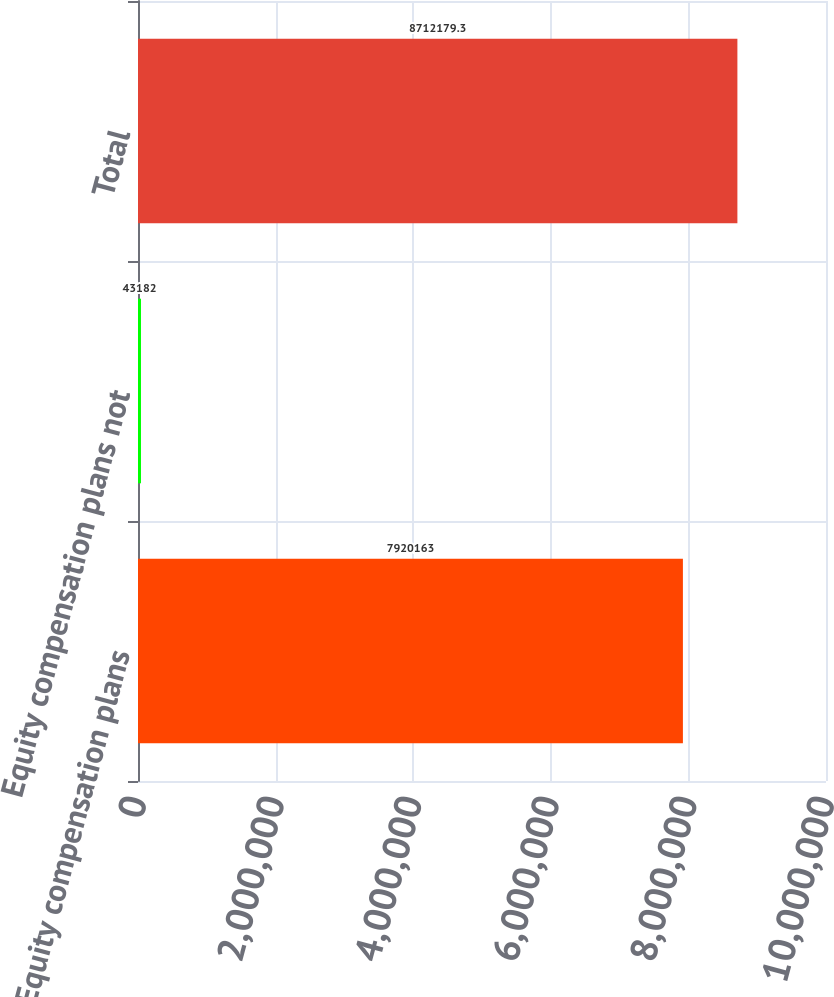Convert chart to OTSL. <chart><loc_0><loc_0><loc_500><loc_500><bar_chart><fcel>Equity compensation plans<fcel>Equity compensation plans not<fcel>Total<nl><fcel>7.92016e+06<fcel>43182<fcel>8.71218e+06<nl></chart> 